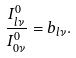Convert formula to latex. <formula><loc_0><loc_0><loc_500><loc_500>\frac { I _ { l \nu } ^ { 0 } } { I _ { 0 \nu } ^ { 0 } } = b _ { l \nu } .</formula> 